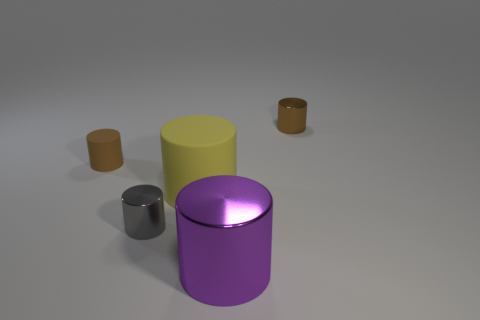There is a metallic cylinder that is behind the gray metallic cylinder; is it the same size as the yellow matte object?
Your answer should be compact. No. What number of other things are there of the same color as the large rubber object?
Offer a terse response. 0. What is the material of the large yellow cylinder?
Make the answer very short. Rubber. What material is the tiny object that is right of the tiny rubber cylinder and in front of the brown metallic object?
Your response must be concise. Metal. What number of objects are cylinders that are on the right side of the big matte object or large gray cubes?
Provide a short and direct response. 2. Are there any purple cylinders of the same size as the yellow matte object?
Keep it short and to the point. Yes. What number of things are left of the small gray thing and on the right side of the purple thing?
Your answer should be very brief. 0. There is a yellow rubber thing; how many purple cylinders are right of it?
Provide a short and direct response. 1. Is there a large purple metallic object of the same shape as the brown rubber thing?
Give a very brief answer. Yes. What number of cylinders are either small brown objects or yellow rubber objects?
Ensure brevity in your answer.  3. 